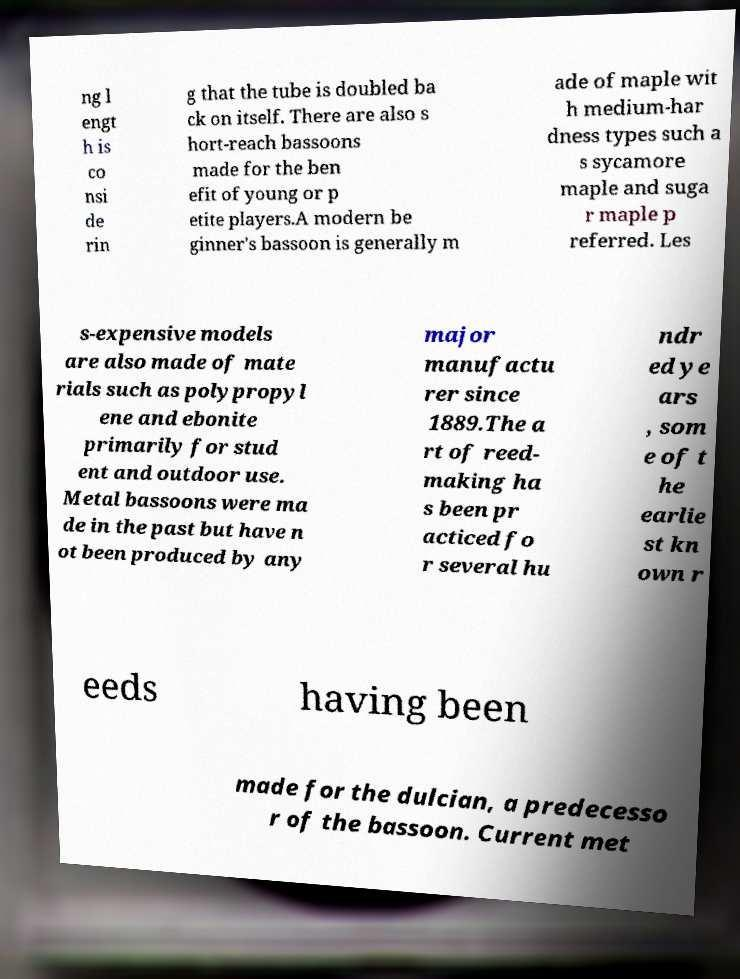What messages or text are displayed in this image? I need them in a readable, typed format. ng l engt h is co nsi de rin g that the tube is doubled ba ck on itself. There are also s hort-reach bassoons made for the ben efit of young or p etite players.A modern be ginner's bassoon is generally m ade of maple wit h medium-har dness types such a s sycamore maple and suga r maple p referred. Les s-expensive models are also made of mate rials such as polypropyl ene and ebonite primarily for stud ent and outdoor use. Metal bassoons were ma de in the past but have n ot been produced by any major manufactu rer since 1889.The a rt of reed- making ha s been pr acticed fo r several hu ndr ed ye ars , som e of t he earlie st kn own r eeds having been made for the dulcian, a predecesso r of the bassoon. Current met 